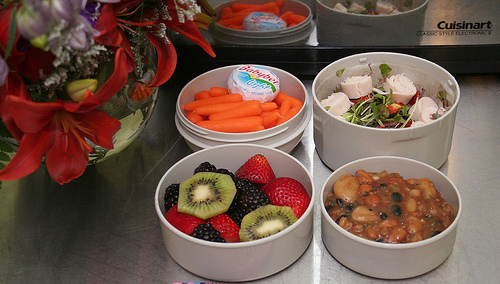<image>
Is there a kiwi on the blackberry? Yes. Looking at the image, I can see the kiwi is positioned on top of the blackberry, with the blackberry providing support. Is there a flower to the right of the carrot? No. The flower is not to the right of the carrot. The horizontal positioning shows a different relationship. 